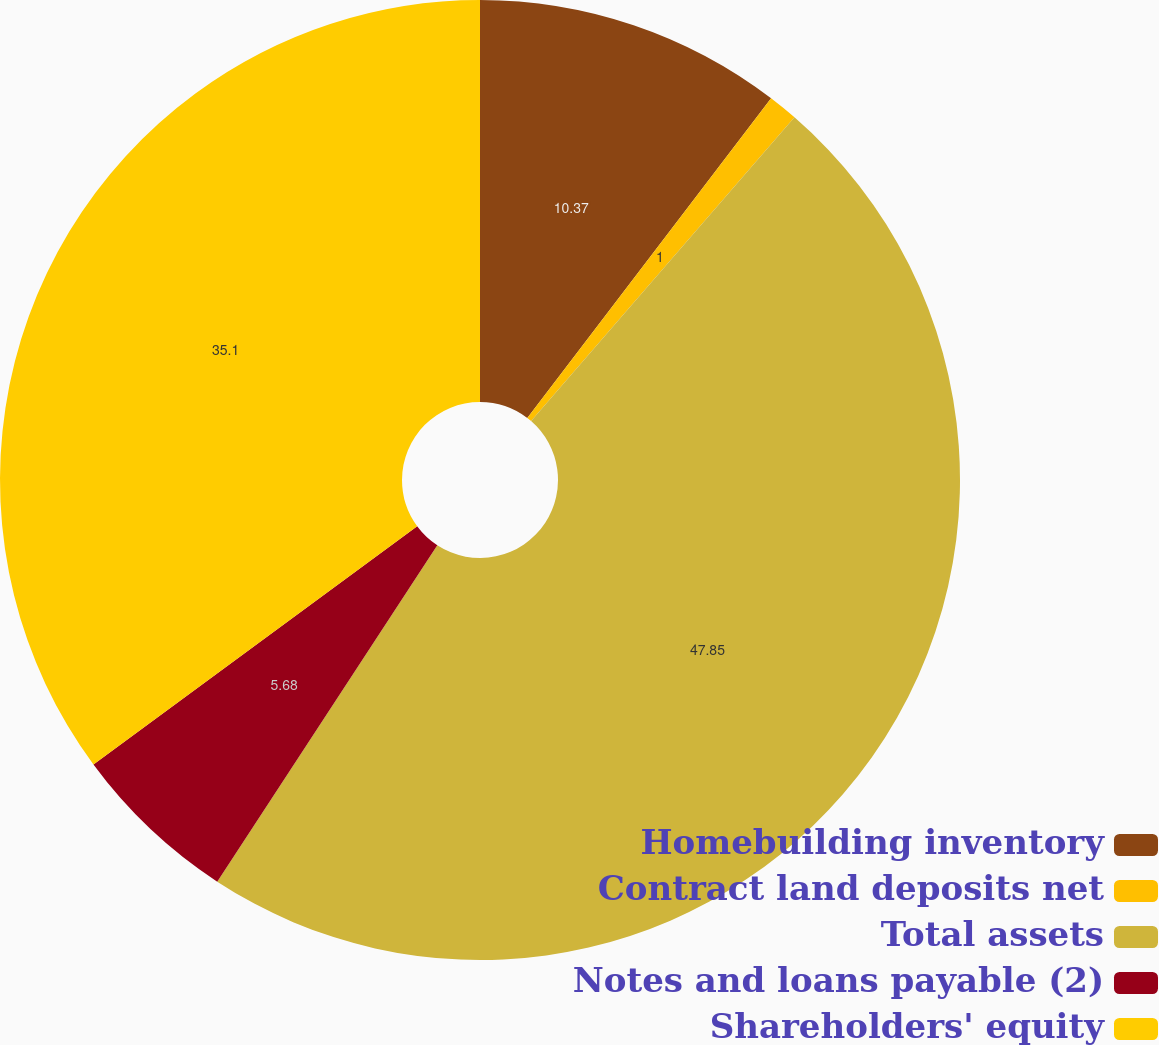<chart> <loc_0><loc_0><loc_500><loc_500><pie_chart><fcel>Homebuilding inventory<fcel>Contract land deposits net<fcel>Total assets<fcel>Notes and loans payable (2)<fcel>Shareholders' equity<nl><fcel>10.37%<fcel>1.0%<fcel>47.85%<fcel>5.68%<fcel>35.1%<nl></chart> 